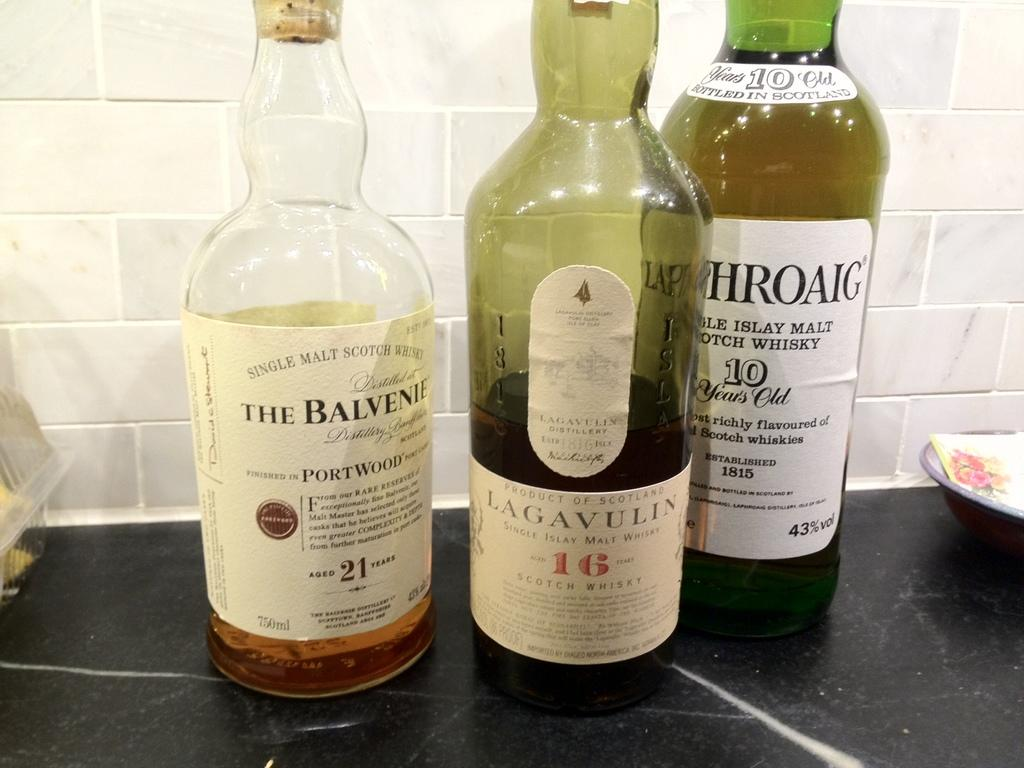Provide a one-sentence caption for the provided image. The Balvenie whiskey is next to two other bottles. 